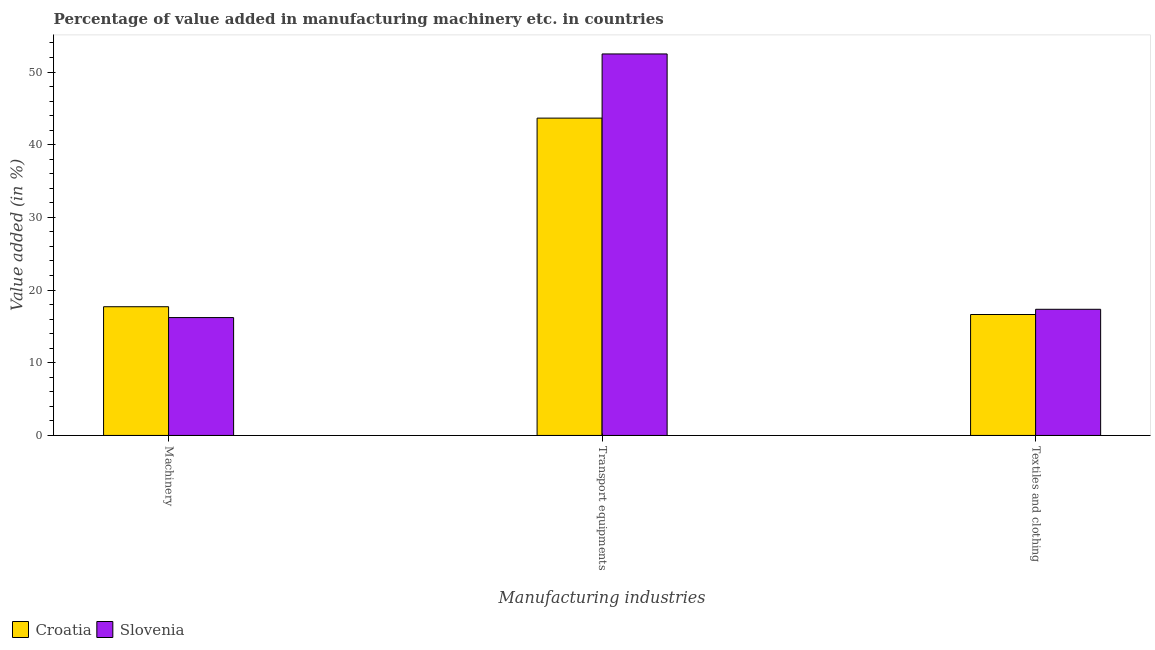How many different coloured bars are there?
Provide a short and direct response. 2. How many groups of bars are there?
Offer a terse response. 3. Are the number of bars per tick equal to the number of legend labels?
Your response must be concise. Yes. Are the number of bars on each tick of the X-axis equal?
Your response must be concise. Yes. What is the label of the 3rd group of bars from the left?
Provide a succinct answer. Textiles and clothing. What is the value added in manufacturing textile and clothing in Croatia?
Offer a terse response. 16.64. Across all countries, what is the maximum value added in manufacturing transport equipments?
Provide a short and direct response. 52.48. Across all countries, what is the minimum value added in manufacturing machinery?
Provide a short and direct response. 16.22. In which country was the value added in manufacturing transport equipments maximum?
Offer a terse response. Slovenia. In which country was the value added in manufacturing machinery minimum?
Your response must be concise. Slovenia. What is the total value added in manufacturing transport equipments in the graph?
Offer a very short reply. 96.14. What is the difference between the value added in manufacturing textile and clothing in Croatia and that in Slovenia?
Give a very brief answer. -0.72. What is the difference between the value added in manufacturing machinery in Croatia and the value added in manufacturing transport equipments in Slovenia?
Your answer should be compact. -34.78. What is the average value added in manufacturing transport equipments per country?
Your answer should be compact. 48.07. What is the difference between the value added in manufacturing textile and clothing and value added in manufacturing machinery in Croatia?
Offer a very short reply. -1.07. What is the ratio of the value added in manufacturing machinery in Slovenia to that in Croatia?
Provide a succinct answer. 0.92. Is the difference between the value added in manufacturing transport equipments in Croatia and Slovenia greater than the difference between the value added in manufacturing machinery in Croatia and Slovenia?
Offer a terse response. No. What is the difference between the highest and the second highest value added in manufacturing textile and clothing?
Ensure brevity in your answer.  0.72. What is the difference between the highest and the lowest value added in manufacturing machinery?
Offer a terse response. 1.49. In how many countries, is the value added in manufacturing transport equipments greater than the average value added in manufacturing transport equipments taken over all countries?
Provide a succinct answer. 1. What does the 1st bar from the left in Transport equipments represents?
Offer a terse response. Croatia. What does the 1st bar from the right in Transport equipments represents?
Your response must be concise. Slovenia. How many bars are there?
Provide a short and direct response. 6. Are all the bars in the graph horizontal?
Your answer should be very brief. No. What is the difference between two consecutive major ticks on the Y-axis?
Keep it short and to the point. 10. Does the graph contain grids?
Offer a very short reply. No. How many legend labels are there?
Offer a very short reply. 2. What is the title of the graph?
Your answer should be compact. Percentage of value added in manufacturing machinery etc. in countries. Does "Myanmar" appear as one of the legend labels in the graph?
Your answer should be very brief. No. What is the label or title of the X-axis?
Provide a succinct answer. Manufacturing industries. What is the label or title of the Y-axis?
Make the answer very short. Value added (in %). What is the Value added (in %) of Croatia in Machinery?
Make the answer very short. 17.71. What is the Value added (in %) in Slovenia in Machinery?
Provide a short and direct response. 16.22. What is the Value added (in %) of Croatia in Transport equipments?
Give a very brief answer. 43.66. What is the Value added (in %) in Slovenia in Transport equipments?
Offer a very short reply. 52.48. What is the Value added (in %) of Croatia in Textiles and clothing?
Offer a very short reply. 16.64. What is the Value added (in %) in Slovenia in Textiles and clothing?
Your response must be concise. 17.35. Across all Manufacturing industries, what is the maximum Value added (in %) of Croatia?
Keep it short and to the point. 43.66. Across all Manufacturing industries, what is the maximum Value added (in %) of Slovenia?
Provide a succinct answer. 52.48. Across all Manufacturing industries, what is the minimum Value added (in %) of Croatia?
Make the answer very short. 16.64. Across all Manufacturing industries, what is the minimum Value added (in %) in Slovenia?
Ensure brevity in your answer.  16.22. What is the total Value added (in %) in Croatia in the graph?
Keep it short and to the point. 78. What is the total Value added (in %) of Slovenia in the graph?
Your answer should be very brief. 86.05. What is the difference between the Value added (in %) in Croatia in Machinery and that in Transport equipments?
Provide a succinct answer. -25.95. What is the difference between the Value added (in %) in Slovenia in Machinery and that in Transport equipments?
Ensure brevity in your answer.  -36.27. What is the difference between the Value added (in %) of Croatia in Machinery and that in Textiles and clothing?
Provide a short and direct response. 1.07. What is the difference between the Value added (in %) of Slovenia in Machinery and that in Textiles and clothing?
Ensure brevity in your answer.  -1.14. What is the difference between the Value added (in %) in Croatia in Transport equipments and that in Textiles and clothing?
Provide a short and direct response. 27.02. What is the difference between the Value added (in %) of Slovenia in Transport equipments and that in Textiles and clothing?
Provide a short and direct response. 35.13. What is the difference between the Value added (in %) of Croatia in Machinery and the Value added (in %) of Slovenia in Transport equipments?
Provide a short and direct response. -34.78. What is the difference between the Value added (in %) of Croatia in Machinery and the Value added (in %) of Slovenia in Textiles and clothing?
Your answer should be compact. 0.35. What is the difference between the Value added (in %) of Croatia in Transport equipments and the Value added (in %) of Slovenia in Textiles and clothing?
Offer a very short reply. 26.3. What is the average Value added (in %) in Croatia per Manufacturing industries?
Keep it short and to the point. 26. What is the average Value added (in %) in Slovenia per Manufacturing industries?
Provide a succinct answer. 28.68. What is the difference between the Value added (in %) of Croatia and Value added (in %) of Slovenia in Machinery?
Offer a very short reply. 1.49. What is the difference between the Value added (in %) of Croatia and Value added (in %) of Slovenia in Transport equipments?
Keep it short and to the point. -8.83. What is the difference between the Value added (in %) of Croatia and Value added (in %) of Slovenia in Textiles and clothing?
Your answer should be compact. -0.72. What is the ratio of the Value added (in %) in Croatia in Machinery to that in Transport equipments?
Keep it short and to the point. 0.41. What is the ratio of the Value added (in %) in Slovenia in Machinery to that in Transport equipments?
Your response must be concise. 0.31. What is the ratio of the Value added (in %) of Croatia in Machinery to that in Textiles and clothing?
Your answer should be compact. 1.06. What is the ratio of the Value added (in %) of Slovenia in Machinery to that in Textiles and clothing?
Make the answer very short. 0.93. What is the ratio of the Value added (in %) of Croatia in Transport equipments to that in Textiles and clothing?
Offer a very short reply. 2.62. What is the ratio of the Value added (in %) in Slovenia in Transport equipments to that in Textiles and clothing?
Ensure brevity in your answer.  3.02. What is the difference between the highest and the second highest Value added (in %) of Croatia?
Provide a succinct answer. 25.95. What is the difference between the highest and the second highest Value added (in %) of Slovenia?
Your response must be concise. 35.13. What is the difference between the highest and the lowest Value added (in %) in Croatia?
Provide a succinct answer. 27.02. What is the difference between the highest and the lowest Value added (in %) of Slovenia?
Make the answer very short. 36.27. 